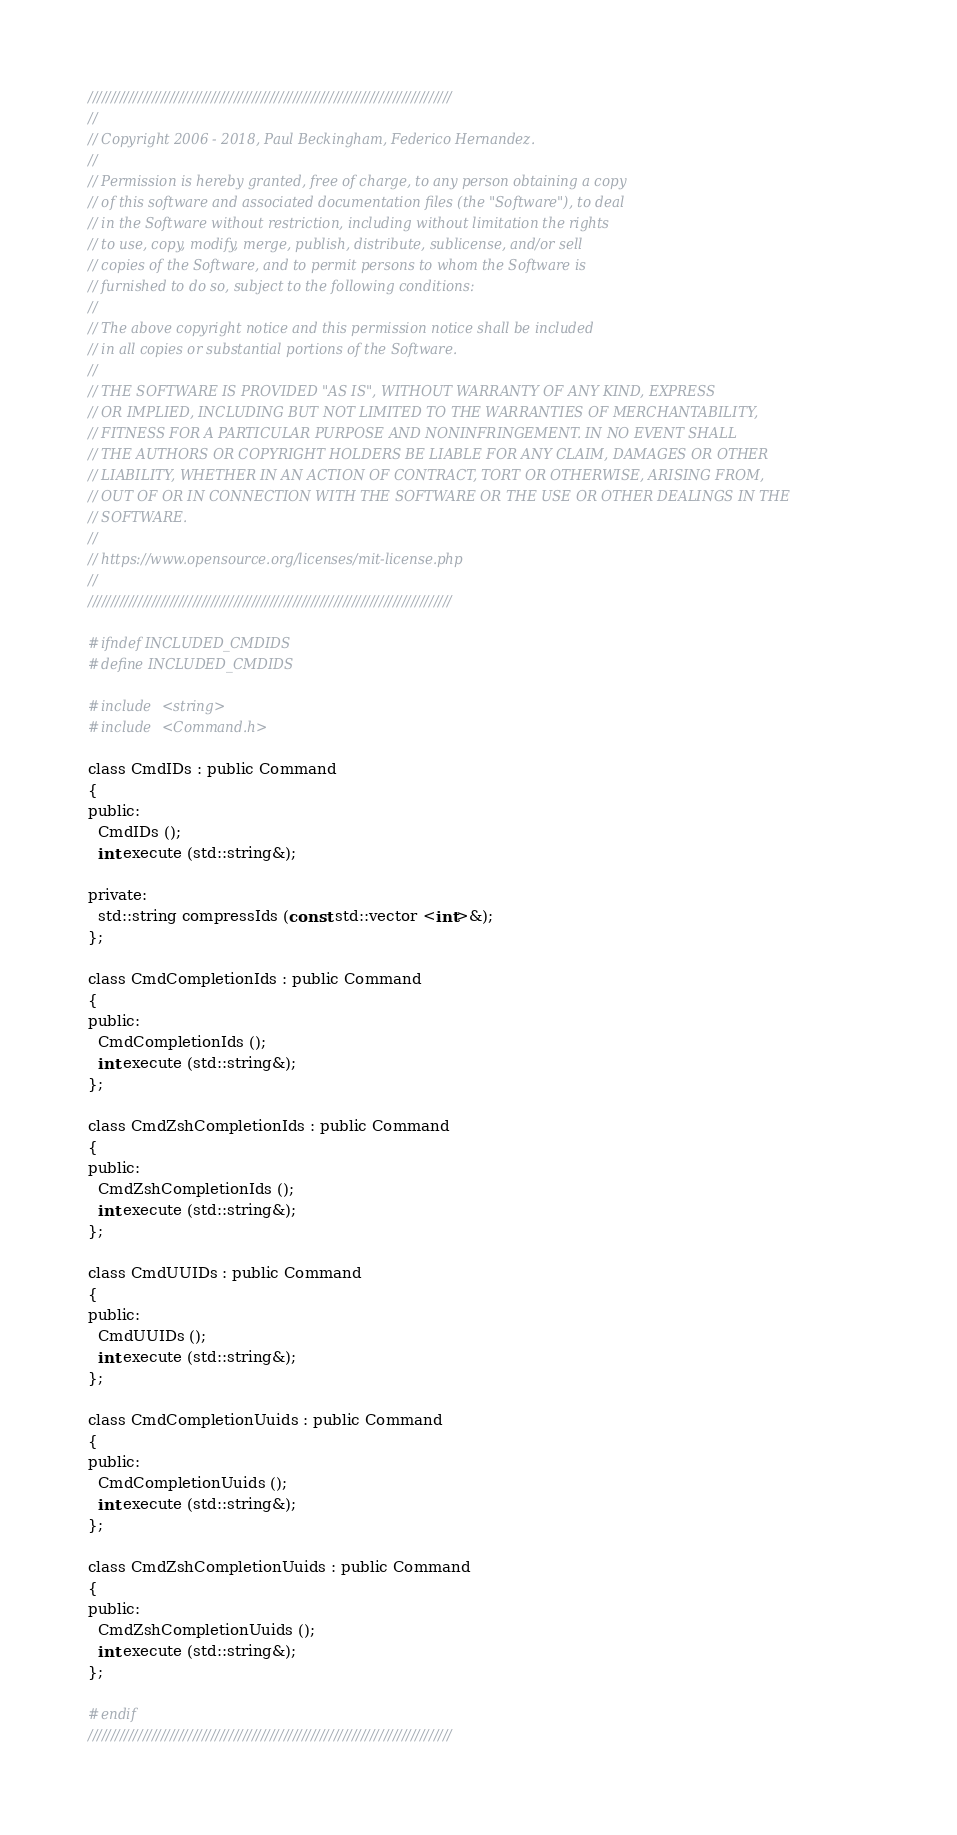<code> <loc_0><loc_0><loc_500><loc_500><_C_>////////////////////////////////////////////////////////////////////////////////
//
// Copyright 2006 - 2018, Paul Beckingham, Federico Hernandez.
//
// Permission is hereby granted, free of charge, to any person obtaining a copy
// of this software and associated documentation files (the "Software"), to deal
// in the Software without restriction, including without limitation the rights
// to use, copy, modify, merge, publish, distribute, sublicense, and/or sell
// copies of the Software, and to permit persons to whom the Software is
// furnished to do so, subject to the following conditions:
//
// The above copyright notice and this permission notice shall be included
// in all copies or substantial portions of the Software.
//
// THE SOFTWARE IS PROVIDED "AS IS", WITHOUT WARRANTY OF ANY KIND, EXPRESS
// OR IMPLIED, INCLUDING BUT NOT LIMITED TO THE WARRANTIES OF MERCHANTABILITY,
// FITNESS FOR A PARTICULAR PURPOSE AND NONINFRINGEMENT. IN NO EVENT SHALL
// THE AUTHORS OR COPYRIGHT HOLDERS BE LIABLE FOR ANY CLAIM, DAMAGES OR OTHER
// LIABILITY, WHETHER IN AN ACTION OF CONTRACT, TORT OR OTHERWISE, ARISING FROM,
// OUT OF OR IN CONNECTION WITH THE SOFTWARE OR THE USE OR OTHER DEALINGS IN THE
// SOFTWARE.
//
// https://www.opensource.org/licenses/mit-license.php
//
////////////////////////////////////////////////////////////////////////////////

#ifndef INCLUDED_CMDIDS
#define INCLUDED_CMDIDS

#include <string>
#include <Command.h>

class CmdIDs : public Command
{
public:
  CmdIDs ();
  int execute (std::string&);

private:
  std::string compressIds (const std::vector <int>&);
};

class CmdCompletionIds : public Command
{
public:
  CmdCompletionIds ();
  int execute (std::string&);
};

class CmdZshCompletionIds : public Command
{
public:
  CmdZshCompletionIds ();
  int execute (std::string&);
};

class CmdUUIDs : public Command
{
public:
  CmdUUIDs ();
  int execute (std::string&);
};

class CmdCompletionUuids : public Command
{
public:
  CmdCompletionUuids ();
  int execute (std::string&);
};

class CmdZshCompletionUuids : public Command
{
public:
  CmdZshCompletionUuids ();
  int execute (std::string&);
};

#endif
////////////////////////////////////////////////////////////////////////////////
</code> 